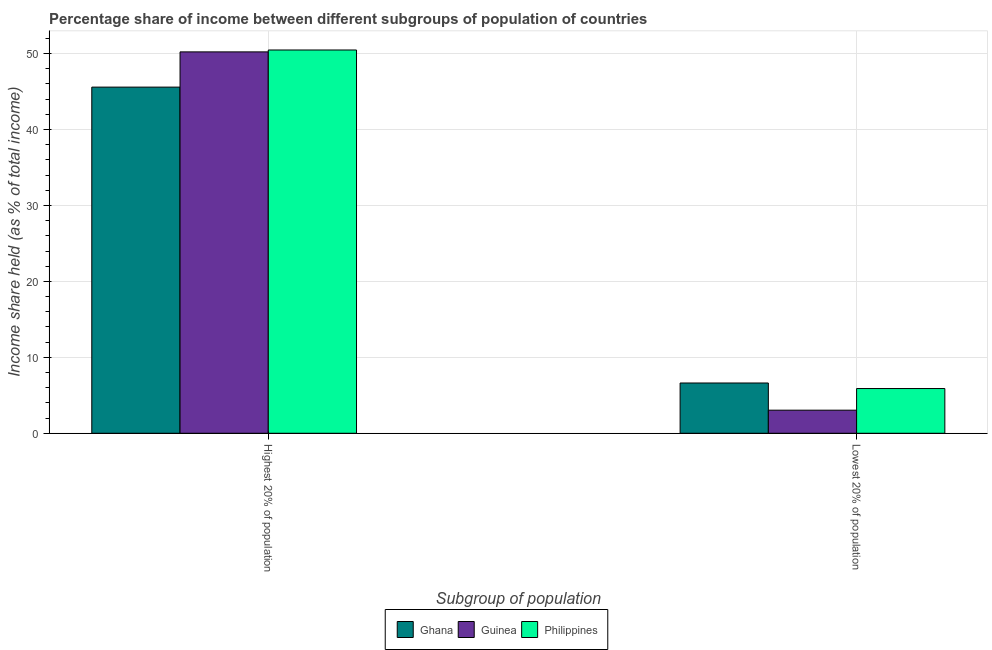How many groups of bars are there?
Your response must be concise. 2. Are the number of bars per tick equal to the number of legend labels?
Make the answer very short. Yes. How many bars are there on the 1st tick from the right?
Your response must be concise. 3. What is the label of the 2nd group of bars from the left?
Offer a terse response. Lowest 20% of population. What is the income share held by lowest 20% of the population in Guinea?
Provide a succinct answer. 3.04. Across all countries, what is the maximum income share held by highest 20% of the population?
Your answer should be compact. 50.47. Across all countries, what is the minimum income share held by lowest 20% of the population?
Ensure brevity in your answer.  3.04. In which country was the income share held by highest 20% of the population minimum?
Provide a succinct answer. Ghana. What is the total income share held by lowest 20% of the population in the graph?
Make the answer very short. 15.55. What is the difference between the income share held by highest 20% of the population in Guinea and that in Ghana?
Your response must be concise. 4.64. What is the difference between the income share held by highest 20% of the population in Philippines and the income share held by lowest 20% of the population in Guinea?
Provide a succinct answer. 47.43. What is the average income share held by highest 20% of the population per country?
Your answer should be very brief. 48.76. What is the difference between the income share held by lowest 20% of the population and income share held by highest 20% of the population in Philippines?
Provide a short and direct response. -44.58. In how many countries, is the income share held by lowest 20% of the population greater than 26 %?
Make the answer very short. 0. What is the ratio of the income share held by lowest 20% of the population in Guinea to that in Ghana?
Provide a succinct answer. 0.46. Is the income share held by lowest 20% of the population in Ghana less than that in Philippines?
Offer a terse response. No. In how many countries, is the income share held by highest 20% of the population greater than the average income share held by highest 20% of the population taken over all countries?
Ensure brevity in your answer.  2. What does the 2nd bar from the left in Lowest 20% of population represents?
Provide a short and direct response. Guinea. What does the 2nd bar from the right in Lowest 20% of population represents?
Keep it short and to the point. Guinea. How many bars are there?
Your response must be concise. 6. How many countries are there in the graph?
Provide a succinct answer. 3. What is the difference between two consecutive major ticks on the Y-axis?
Keep it short and to the point. 10. Does the graph contain grids?
Make the answer very short. Yes. Where does the legend appear in the graph?
Your answer should be very brief. Bottom center. How are the legend labels stacked?
Provide a succinct answer. Horizontal. What is the title of the graph?
Offer a terse response. Percentage share of income between different subgroups of population of countries. Does "East Asia (all income levels)" appear as one of the legend labels in the graph?
Your answer should be compact. No. What is the label or title of the X-axis?
Offer a very short reply. Subgroup of population. What is the label or title of the Y-axis?
Your answer should be compact. Income share held (as % of total income). What is the Income share held (as % of total income) in Ghana in Highest 20% of population?
Provide a succinct answer. 45.58. What is the Income share held (as % of total income) of Guinea in Highest 20% of population?
Your response must be concise. 50.22. What is the Income share held (as % of total income) of Philippines in Highest 20% of population?
Offer a terse response. 50.47. What is the Income share held (as % of total income) in Ghana in Lowest 20% of population?
Give a very brief answer. 6.62. What is the Income share held (as % of total income) in Guinea in Lowest 20% of population?
Your answer should be compact. 3.04. What is the Income share held (as % of total income) of Philippines in Lowest 20% of population?
Provide a succinct answer. 5.89. Across all Subgroup of population, what is the maximum Income share held (as % of total income) in Ghana?
Give a very brief answer. 45.58. Across all Subgroup of population, what is the maximum Income share held (as % of total income) in Guinea?
Provide a short and direct response. 50.22. Across all Subgroup of population, what is the maximum Income share held (as % of total income) in Philippines?
Your answer should be compact. 50.47. Across all Subgroup of population, what is the minimum Income share held (as % of total income) in Ghana?
Your answer should be compact. 6.62. Across all Subgroup of population, what is the minimum Income share held (as % of total income) of Guinea?
Provide a short and direct response. 3.04. Across all Subgroup of population, what is the minimum Income share held (as % of total income) in Philippines?
Provide a short and direct response. 5.89. What is the total Income share held (as % of total income) in Ghana in the graph?
Offer a very short reply. 52.2. What is the total Income share held (as % of total income) of Guinea in the graph?
Your answer should be compact. 53.26. What is the total Income share held (as % of total income) in Philippines in the graph?
Keep it short and to the point. 56.36. What is the difference between the Income share held (as % of total income) in Ghana in Highest 20% of population and that in Lowest 20% of population?
Provide a succinct answer. 38.96. What is the difference between the Income share held (as % of total income) of Guinea in Highest 20% of population and that in Lowest 20% of population?
Ensure brevity in your answer.  47.18. What is the difference between the Income share held (as % of total income) of Philippines in Highest 20% of population and that in Lowest 20% of population?
Give a very brief answer. 44.58. What is the difference between the Income share held (as % of total income) in Ghana in Highest 20% of population and the Income share held (as % of total income) in Guinea in Lowest 20% of population?
Your answer should be very brief. 42.54. What is the difference between the Income share held (as % of total income) of Ghana in Highest 20% of population and the Income share held (as % of total income) of Philippines in Lowest 20% of population?
Your response must be concise. 39.69. What is the difference between the Income share held (as % of total income) in Guinea in Highest 20% of population and the Income share held (as % of total income) in Philippines in Lowest 20% of population?
Your response must be concise. 44.33. What is the average Income share held (as % of total income) of Ghana per Subgroup of population?
Give a very brief answer. 26.1. What is the average Income share held (as % of total income) of Guinea per Subgroup of population?
Your response must be concise. 26.63. What is the average Income share held (as % of total income) in Philippines per Subgroup of population?
Your answer should be very brief. 28.18. What is the difference between the Income share held (as % of total income) of Ghana and Income share held (as % of total income) of Guinea in Highest 20% of population?
Provide a short and direct response. -4.64. What is the difference between the Income share held (as % of total income) of Ghana and Income share held (as % of total income) of Philippines in Highest 20% of population?
Provide a short and direct response. -4.89. What is the difference between the Income share held (as % of total income) in Ghana and Income share held (as % of total income) in Guinea in Lowest 20% of population?
Offer a terse response. 3.58. What is the difference between the Income share held (as % of total income) in Ghana and Income share held (as % of total income) in Philippines in Lowest 20% of population?
Offer a very short reply. 0.73. What is the difference between the Income share held (as % of total income) of Guinea and Income share held (as % of total income) of Philippines in Lowest 20% of population?
Make the answer very short. -2.85. What is the ratio of the Income share held (as % of total income) in Ghana in Highest 20% of population to that in Lowest 20% of population?
Provide a short and direct response. 6.89. What is the ratio of the Income share held (as % of total income) of Guinea in Highest 20% of population to that in Lowest 20% of population?
Your response must be concise. 16.52. What is the ratio of the Income share held (as % of total income) of Philippines in Highest 20% of population to that in Lowest 20% of population?
Give a very brief answer. 8.57. What is the difference between the highest and the second highest Income share held (as % of total income) of Ghana?
Make the answer very short. 38.96. What is the difference between the highest and the second highest Income share held (as % of total income) in Guinea?
Your response must be concise. 47.18. What is the difference between the highest and the second highest Income share held (as % of total income) in Philippines?
Your answer should be compact. 44.58. What is the difference between the highest and the lowest Income share held (as % of total income) in Ghana?
Your response must be concise. 38.96. What is the difference between the highest and the lowest Income share held (as % of total income) in Guinea?
Offer a very short reply. 47.18. What is the difference between the highest and the lowest Income share held (as % of total income) of Philippines?
Ensure brevity in your answer.  44.58. 